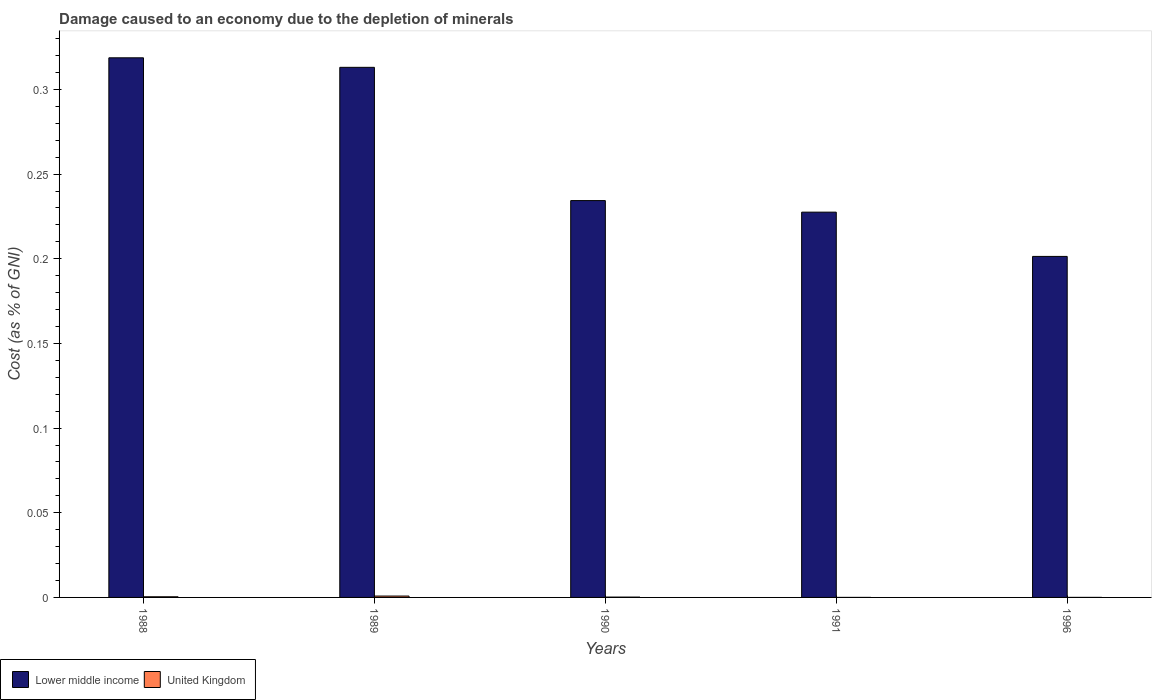How many groups of bars are there?
Ensure brevity in your answer.  5. Are the number of bars per tick equal to the number of legend labels?
Provide a succinct answer. Yes. How many bars are there on the 4th tick from the left?
Give a very brief answer. 2. What is the cost of damage caused due to the depletion of minerals in United Kingdom in 1996?
Provide a short and direct response. 1.66877310500276e-5. Across all years, what is the maximum cost of damage caused due to the depletion of minerals in United Kingdom?
Give a very brief answer. 0. Across all years, what is the minimum cost of damage caused due to the depletion of minerals in Lower middle income?
Offer a terse response. 0.2. In which year was the cost of damage caused due to the depletion of minerals in Lower middle income minimum?
Provide a short and direct response. 1996. What is the total cost of damage caused due to the depletion of minerals in United Kingdom in the graph?
Offer a very short reply. 0. What is the difference between the cost of damage caused due to the depletion of minerals in Lower middle income in 1990 and that in 1991?
Your response must be concise. 0.01. What is the difference between the cost of damage caused due to the depletion of minerals in United Kingdom in 1988 and the cost of damage caused due to the depletion of minerals in Lower middle income in 1990?
Keep it short and to the point. -0.23. What is the average cost of damage caused due to the depletion of minerals in Lower middle income per year?
Provide a short and direct response. 0.26. In the year 1988, what is the difference between the cost of damage caused due to the depletion of minerals in Lower middle income and cost of damage caused due to the depletion of minerals in United Kingdom?
Provide a short and direct response. 0.32. In how many years, is the cost of damage caused due to the depletion of minerals in Lower middle income greater than 0.05 %?
Provide a succinct answer. 5. What is the ratio of the cost of damage caused due to the depletion of minerals in Lower middle income in 1989 to that in 1990?
Offer a terse response. 1.34. Is the cost of damage caused due to the depletion of minerals in Lower middle income in 1988 less than that in 1990?
Provide a short and direct response. No. What is the difference between the highest and the second highest cost of damage caused due to the depletion of minerals in United Kingdom?
Your answer should be compact. 0. What is the difference between the highest and the lowest cost of damage caused due to the depletion of minerals in United Kingdom?
Your response must be concise. 0. Is the sum of the cost of damage caused due to the depletion of minerals in Lower middle income in 1990 and 1991 greater than the maximum cost of damage caused due to the depletion of minerals in United Kingdom across all years?
Ensure brevity in your answer.  Yes. What does the 1st bar from the left in 1991 represents?
Offer a terse response. Lower middle income. What does the 1st bar from the right in 1990 represents?
Give a very brief answer. United Kingdom. Are all the bars in the graph horizontal?
Provide a short and direct response. No. Where does the legend appear in the graph?
Your answer should be compact. Bottom left. How many legend labels are there?
Make the answer very short. 2. How are the legend labels stacked?
Keep it short and to the point. Horizontal. What is the title of the graph?
Make the answer very short. Damage caused to an economy due to the depletion of minerals. Does "Japan" appear as one of the legend labels in the graph?
Offer a terse response. No. What is the label or title of the Y-axis?
Your answer should be very brief. Cost (as % of GNI). What is the Cost (as % of GNI) of Lower middle income in 1988?
Offer a terse response. 0.32. What is the Cost (as % of GNI) in United Kingdom in 1988?
Offer a very short reply. 0. What is the Cost (as % of GNI) of Lower middle income in 1989?
Offer a very short reply. 0.31. What is the Cost (as % of GNI) in United Kingdom in 1989?
Offer a very short reply. 0. What is the Cost (as % of GNI) in Lower middle income in 1990?
Provide a succinct answer. 0.23. What is the Cost (as % of GNI) of United Kingdom in 1990?
Your response must be concise. 0. What is the Cost (as % of GNI) of Lower middle income in 1991?
Your response must be concise. 0.23. What is the Cost (as % of GNI) in United Kingdom in 1991?
Offer a terse response. 1.03453414089376e-5. What is the Cost (as % of GNI) in Lower middle income in 1996?
Offer a terse response. 0.2. What is the Cost (as % of GNI) in United Kingdom in 1996?
Give a very brief answer. 1.66877310500276e-5. Across all years, what is the maximum Cost (as % of GNI) of Lower middle income?
Your answer should be compact. 0.32. Across all years, what is the maximum Cost (as % of GNI) of United Kingdom?
Make the answer very short. 0. Across all years, what is the minimum Cost (as % of GNI) in Lower middle income?
Keep it short and to the point. 0.2. Across all years, what is the minimum Cost (as % of GNI) of United Kingdom?
Offer a very short reply. 1.03453414089376e-5. What is the total Cost (as % of GNI) in Lower middle income in the graph?
Give a very brief answer. 1.3. What is the total Cost (as % of GNI) in United Kingdom in the graph?
Provide a short and direct response. 0. What is the difference between the Cost (as % of GNI) of Lower middle income in 1988 and that in 1989?
Ensure brevity in your answer.  0.01. What is the difference between the Cost (as % of GNI) of United Kingdom in 1988 and that in 1989?
Your answer should be compact. -0. What is the difference between the Cost (as % of GNI) in Lower middle income in 1988 and that in 1990?
Your answer should be compact. 0.08. What is the difference between the Cost (as % of GNI) of United Kingdom in 1988 and that in 1990?
Provide a succinct answer. 0. What is the difference between the Cost (as % of GNI) in Lower middle income in 1988 and that in 1991?
Make the answer very short. 0.09. What is the difference between the Cost (as % of GNI) of Lower middle income in 1988 and that in 1996?
Provide a short and direct response. 0.12. What is the difference between the Cost (as % of GNI) in United Kingdom in 1988 and that in 1996?
Your response must be concise. 0. What is the difference between the Cost (as % of GNI) in Lower middle income in 1989 and that in 1990?
Your answer should be very brief. 0.08. What is the difference between the Cost (as % of GNI) in United Kingdom in 1989 and that in 1990?
Provide a succinct answer. 0. What is the difference between the Cost (as % of GNI) of Lower middle income in 1989 and that in 1991?
Your answer should be very brief. 0.09. What is the difference between the Cost (as % of GNI) in United Kingdom in 1989 and that in 1991?
Your answer should be very brief. 0. What is the difference between the Cost (as % of GNI) of Lower middle income in 1989 and that in 1996?
Keep it short and to the point. 0.11. What is the difference between the Cost (as % of GNI) in United Kingdom in 1989 and that in 1996?
Your response must be concise. 0. What is the difference between the Cost (as % of GNI) in Lower middle income in 1990 and that in 1991?
Make the answer very short. 0.01. What is the difference between the Cost (as % of GNI) of Lower middle income in 1990 and that in 1996?
Provide a succinct answer. 0.03. What is the difference between the Cost (as % of GNI) of United Kingdom in 1990 and that in 1996?
Keep it short and to the point. 0. What is the difference between the Cost (as % of GNI) in Lower middle income in 1991 and that in 1996?
Your answer should be compact. 0.03. What is the difference between the Cost (as % of GNI) in Lower middle income in 1988 and the Cost (as % of GNI) in United Kingdom in 1989?
Your response must be concise. 0.32. What is the difference between the Cost (as % of GNI) of Lower middle income in 1988 and the Cost (as % of GNI) of United Kingdom in 1990?
Offer a terse response. 0.32. What is the difference between the Cost (as % of GNI) of Lower middle income in 1988 and the Cost (as % of GNI) of United Kingdom in 1991?
Keep it short and to the point. 0.32. What is the difference between the Cost (as % of GNI) of Lower middle income in 1988 and the Cost (as % of GNI) of United Kingdom in 1996?
Give a very brief answer. 0.32. What is the difference between the Cost (as % of GNI) of Lower middle income in 1989 and the Cost (as % of GNI) of United Kingdom in 1990?
Give a very brief answer. 0.31. What is the difference between the Cost (as % of GNI) of Lower middle income in 1989 and the Cost (as % of GNI) of United Kingdom in 1991?
Provide a short and direct response. 0.31. What is the difference between the Cost (as % of GNI) of Lower middle income in 1989 and the Cost (as % of GNI) of United Kingdom in 1996?
Your answer should be compact. 0.31. What is the difference between the Cost (as % of GNI) in Lower middle income in 1990 and the Cost (as % of GNI) in United Kingdom in 1991?
Make the answer very short. 0.23. What is the difference between the Cost (as % of GNI) in Lower middle income in 1990 and the Cost (as % of GNI) in United Kingdom in 1996?
Keep it short and to the point. 0.23. What is the difference between the Cost (as % of GNI) in Lower middle income in 1991 and the Cost (as % of GNI) in United Kingdom in 1996?
Offer a terse response. 0.23. What is the average Cost (as % of GNI) in Lower middle income per year?
Provide a short and direct response. 0.26. What is the average Cost (as % of GNI) in United Kingdom per year?
Your answer should be compact. 0. In the year 1988, what is the difference between the Cost (as % of GNI) in Lower middle income and Cost (as % of GNI) in United Kingdom?
Your answer should be very brief. 0.32. In the year 1989, what is the difference between the Cost (as % of GNI) of Lower middle income and Cost (as % of GNI) of United Kingdom?
Offer a very short reply. 0.31. In the year 1990, what is the difference between the Cost (as % of GNI) in Lower middle income and Cost (as % of GNI) in United Kingdom?
Your response must be concise. 0.23. In the year 1991, what is the difference between the Cost (as % of GNI) in Lower middle income and Cost (as % of GNI) in United Kingdom?
Offer a very short reply. 0.23. In the year 1996, what is the difference between the Cost (as % of GNI) in Lower middle income and Cost (as % of GNI) in United Kingdom?
Offer a very short reply. 0.2. What is the ratio of the Cost (as % of GNI) of Lower middle income in 1988 to that in 1989?
Make the answer very short. 1.02. What is the ratio of the Cost (as % of GNI) in United Kingdom in 1988 to that in 1989?
Provide a succinct answer. 0.48. What is the ratio of the Cost (as % of GNI) in Lower middle income in 1988 to that in 1990?
Your answer should be very brief. 1.36. What is the ratio of the Cost (as % of GNI) in United Kingdom in 1988 to that in 1990?
Your answer should be compact. 1.99. What is the ratio of the Cost (as % of GNI) in Lower middle income in 1988 to that in 1991?
Keep it short and to the point. 1.4. What is the ratio of the Cost (as % of GNI) of United Kingdom in 1988 to that in 1991?
Ensure brevity in your answer.  37.29. What is the ratio of the Cost (as % of GNI) of Lower middle income in 1988 to that in 1996?
Provide a short and direct response. 1.58. What is the ratio of the Cost (as % of GNI) in United Kingdom in 1988 to that in 1996?
Your response must be concise. 23.11. What is the ratio of the Cost (as % of GNI) in Lower middle income in 1989 to that in 1990?
Your response must be concise. 1.34. What is the ratio of the Cost (as % of GNI) of United Kingdom in 1989 to that in 1990?
Ensure brevity in your answer.  4.15. What is the ratio of the Cost (as % of GNI) of Lower middle income in 1989 to that in 1991?
Offer a terse response. 1.38. What is the ratio of the Cost (as % of GNI) in United Kingdom in 1989 to that in 1991?
Make the answer very short. 77.92. What is the ratio of the Cost (as % of GNI) of Lower middle income in 1989 to that in 1996?
Your answer should be very brief. 1.55. What is the ratio of the Cost (as % of GNI) of United Kingdom in 1989 to that in 1996?
Ensure brevity in your answer.  48.31. What is the ratio of the Cost (as % of GNI) of Lower middle income in 1990 to that in 1991?
Your answer should be compact. 1.03. What is the ratio of the Cost (as % of GNI) of United Kingdom in 1990 to that in 1991?
Your answer should be compact. 18.78. What is the ratio of the Cost (as % of GNI) in Lower middle income in 1990 to that in 1996?
Offer a very short reply. 1.16. What is the ratio of the Cost (as % of GNI) in United Kingdom in 1990 to that in 1996?
Your response must be concise. 11.64. What is the ratio of the Cost (as % of GNI) of Lower middle income in 1991 to that in 1996?
Make the answer very short. 1.13. What is the ratio of the Cost (as % of GNI) of United Kingdom in 1991 to that in 1996?
Provide a short and direct response. 0.62. What is the difference between the highest and the second highest Cost (as % of GNI) in Lower middle income?
Your answer should be compact. 0.01. What is the difference between the highest and the lowest Cost (as % of GNI) in Lower middle income?
Offer a very short reply. 0.12. What is the difference between the highest and the lowest Cost (as % of GNI) in United Kingdom?
Ensure brevity in your answer.  0. 